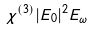<formula> <loc_0><loc_0><loc_500><loc_500>\chi ^ { ( 3 ) } | E _ { 0 } | ^ { 2 } E _ { \omega }</formula> 